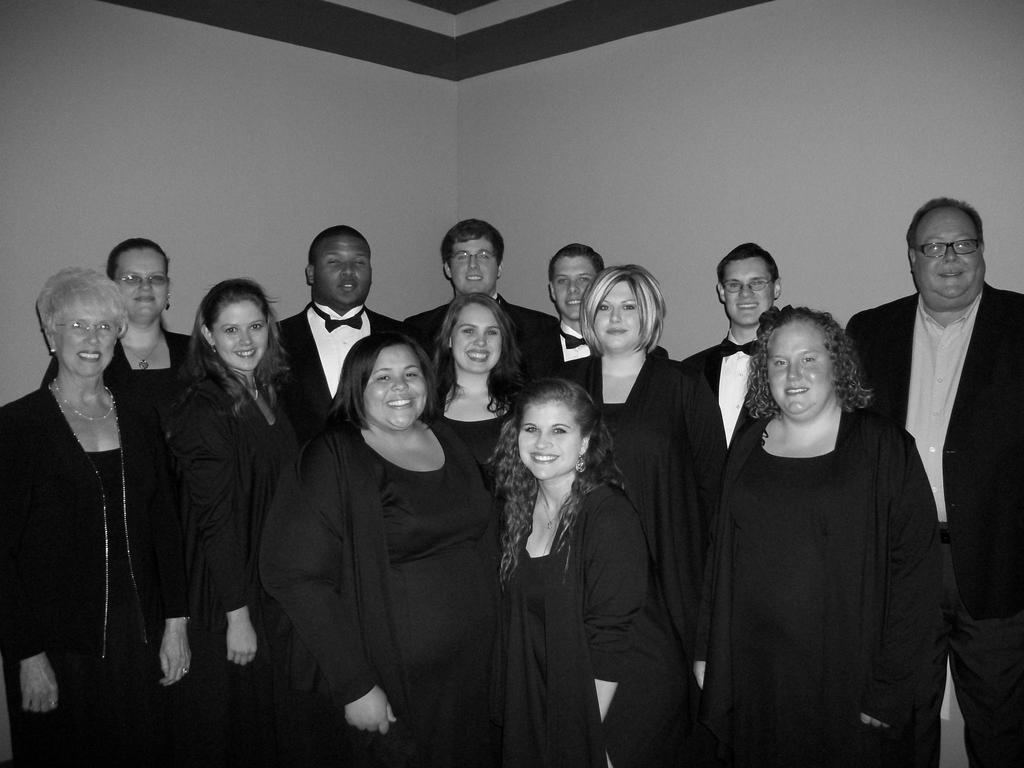What is the color scheme of the image? The image is black and white. What can be seen in the image? There is a group of people in the image. What are the people in the image doing? The people are standing and smiling. What is visible in the background of the image? There is a wall visible in the background of the image. Can you tell me how many wrens are perched on the wall in the image? There are no wrens present in the image; it features a group of people standing and smiling. What type of coach is visible in the image? There is no coach present in the image. 